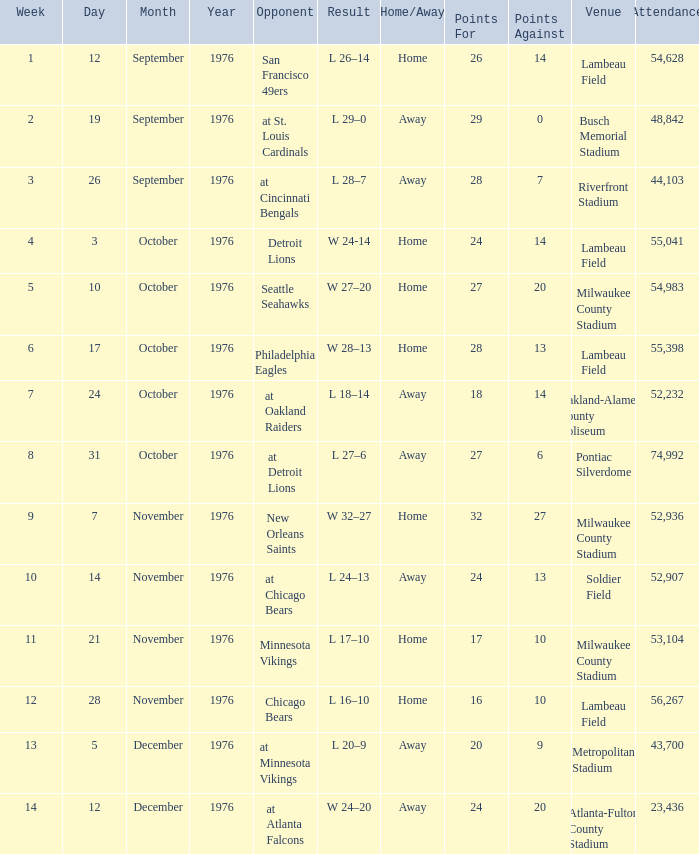What is the typical attendance for the game on september 26, 1976? 44103.0. 